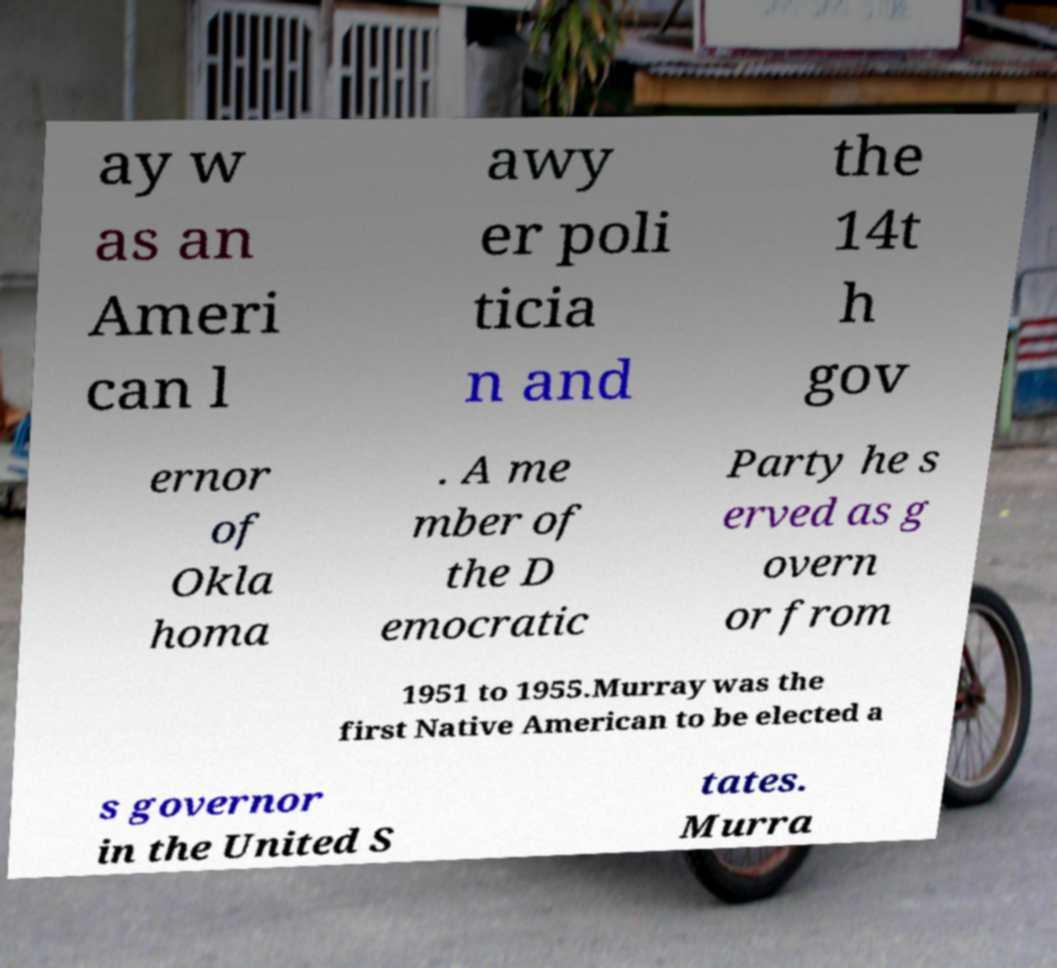Please read and relay the text visible in this image. What does it say? ay w as an Ameri can l awy er poli ticia n and the 14t h gov ernor of Okla homa . A me mber of the D emocratic Party he s erved as g overn or from 1951 to 1955.Murray was the first Native American to be elected a s governor in the United S tates. Murra 